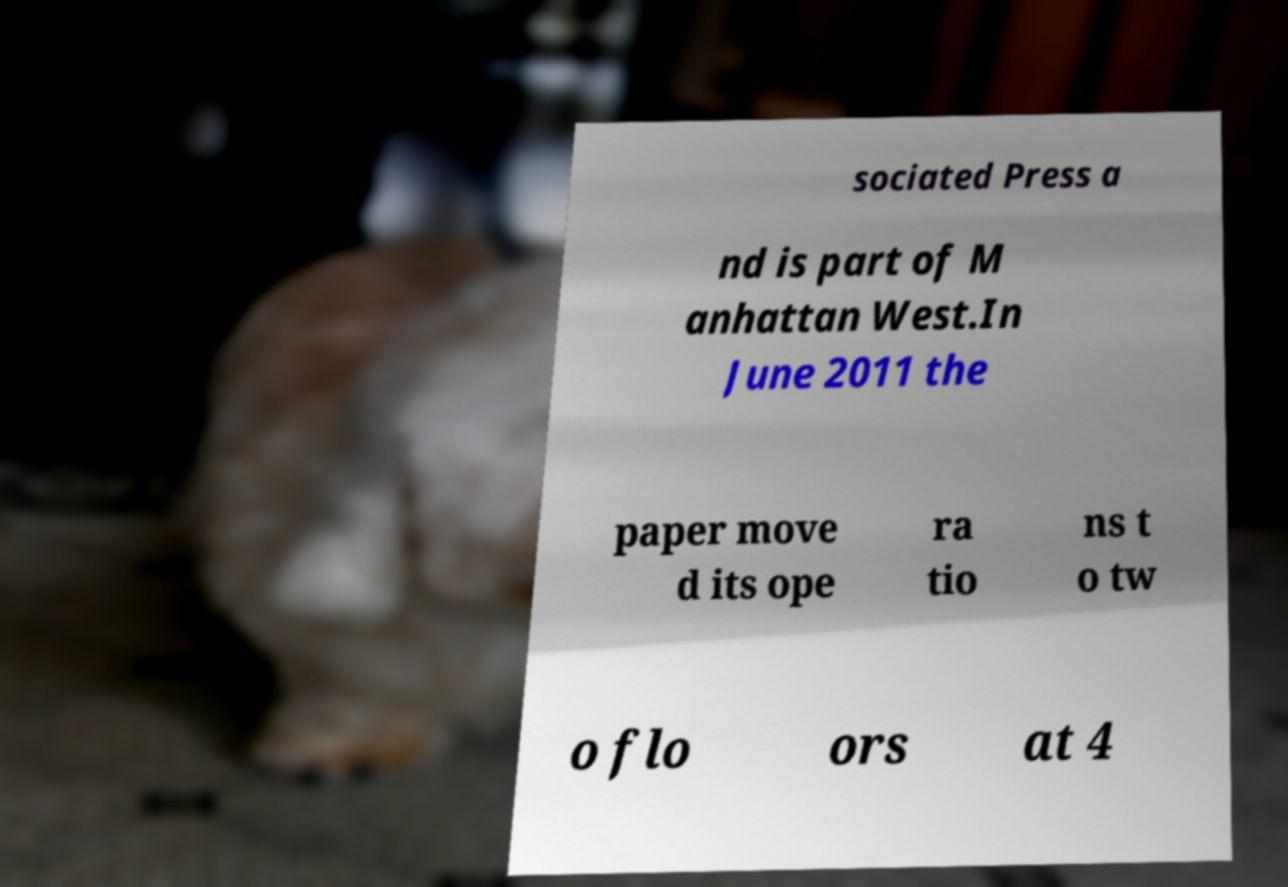Please identify and transcribe the text found in this image. sociated Press a nd is part of M anhattan West.In June 2011 the paper move d its ope ra tio ns t o tw o flo ors at 4 